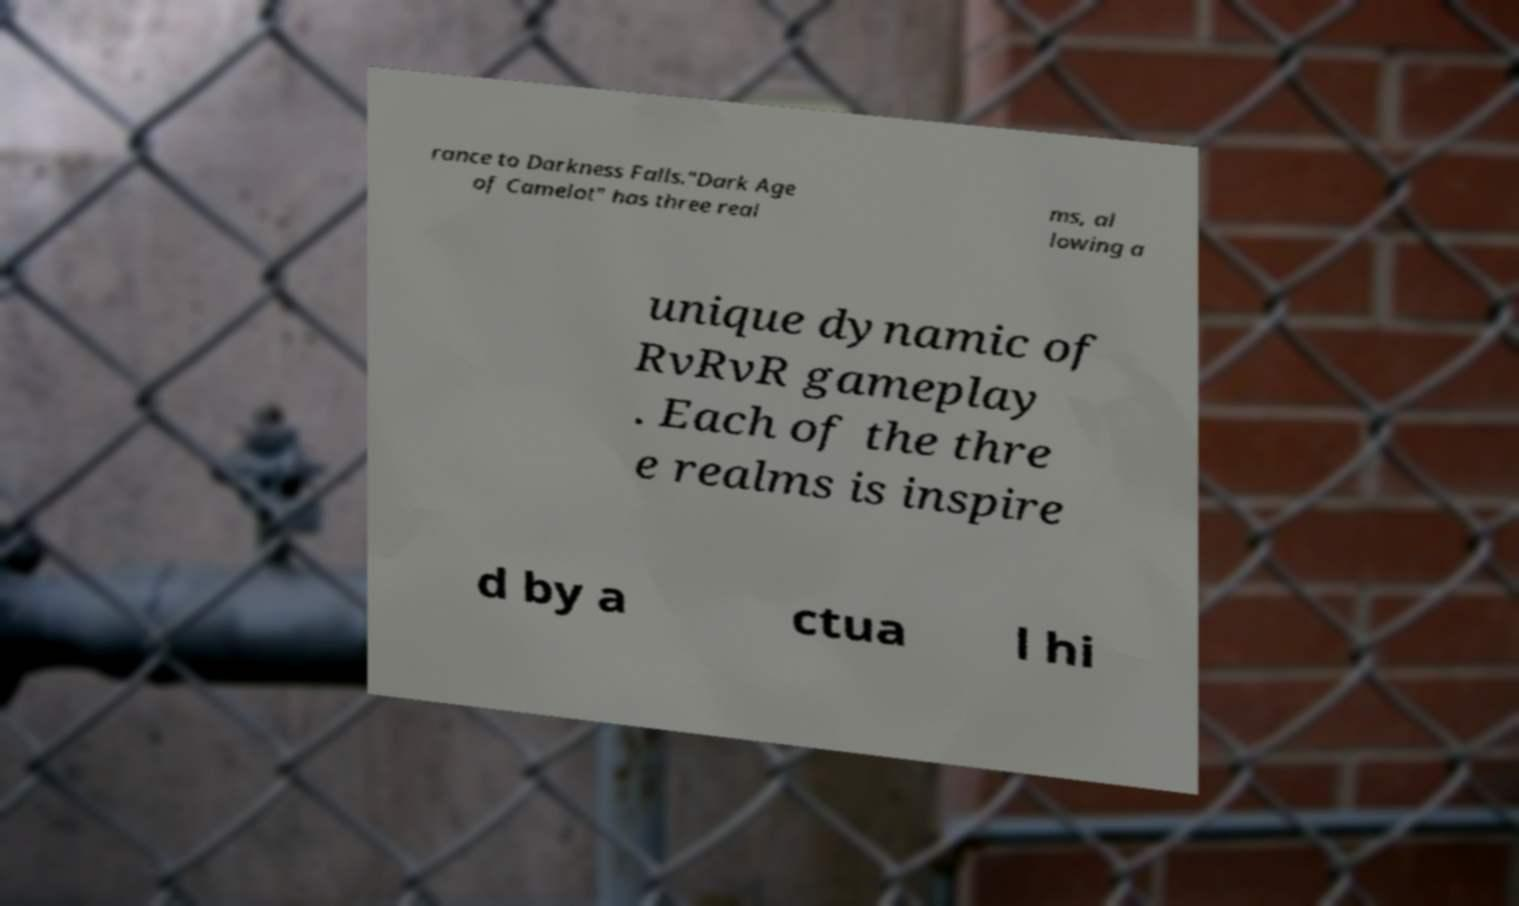There's text embedded in this image that I need extracted. Can you transcribe it verbatim? rance to Darkness Falls."Dark Age of Camelot" has three real ms, al lowing a unique dynamic of RvRvR gameplay . Each of the thre e realms is inspire d by a ctua l hi 